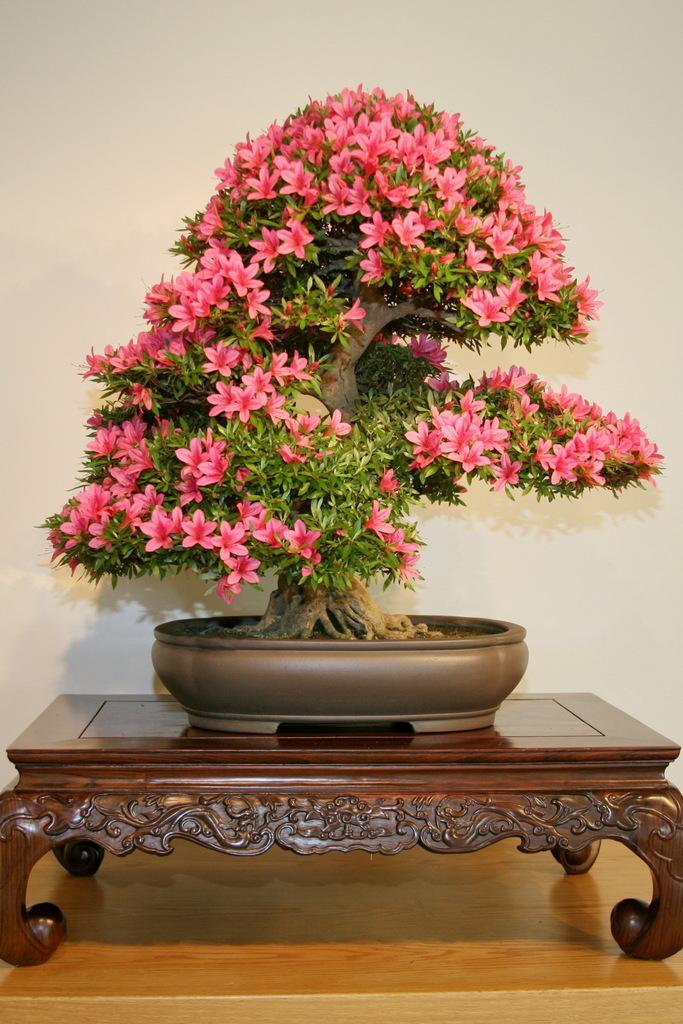What is located in the middle of the image? There is a table in the middle of the image. What is placed on the table? There is a house plant and many flowers on the table. What can be seen in the background of the image? There is a wall in the background of the image. What type of pump is visible in the image? There is no pump present in the image. What things can be observed in the image besides the table and flowers? The only items mentioned in the provided facts are the table, house plant, flowers, and wall. 